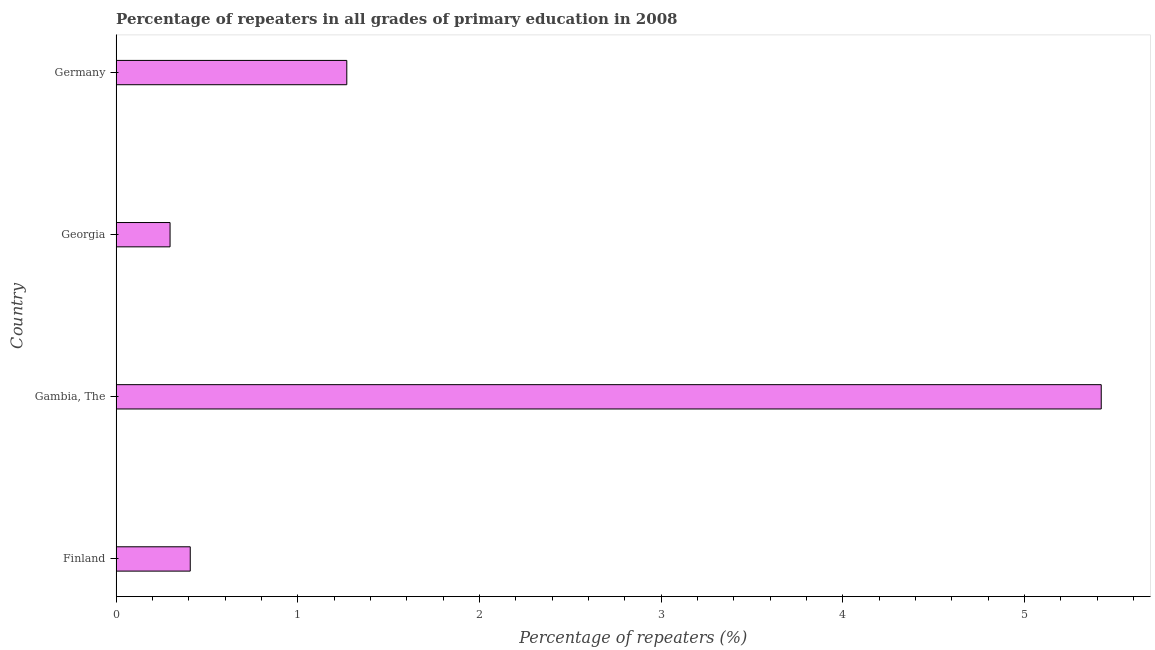Does the graph contain any zero values?
Your answer should be compact. No. What is the title of the graph?
Provide a succinct answer. Percentage of repeaters in all grades of primary education in 2008. What is the label or title of the X-axis?
Make the answer very short. Percentage of repeaters (%). What is the label or title of the Y-axis?
Provide a succinct answer. Country. What is the percentage of repeaters in primary education in Georgia?
Offer a terse response. 0.3. Across all countries, what is the maximum percentage of repeaters in primary education?
Provide a short and direct response. 5.42. Across all countries, what is the minimum percentage of repeaters in primary education?
Your response must be concise. 0.3. In which country was the percentage of repeaters in primary education maximum?
Offer a very short reply. Gambia, The. In which country was the percentage of repeaters in primary education minimum?
Offer a terse response. Georgia. What is the sum of the percentage of repeaters in primary education?
Offer a terse response. 7.4. What is the difference between the percentage of repeaters in primary education in Finland and Germany?
Give a very brief answer. -0.86. What is the average percentage of repeaters in primary education per country?
Provide a short and direct response. 1.85. What is the median percentage of repeaters in primary education?
Your response must be concise. 0.84. What is the ratio of the percentage of repeaters in primary education in Finland to that in Georgia?
Offer a very short reply. 1.37. Is the difference between the percentage of repeaters in primary education in Georgia and Germany greater than the difference between any two countries?
Your response must be concise. No. What is the difference between the highest and the second highest percentage of repeaters in primary education?
Keep it short and to the point. 4.15. Is the sum of the percentage of repeaters in primary education in Finland and Georgia greater than the maximum percentage of repeaters in primary education across all countries?
Your answer should be very brief. No. What is the difference between the highest and the lowest percentage of repeaters in primary education?
Your answer should be compact. 5.13. Are all the bars in the graph horizontal?
Your response must be concise. Yes. Are the values on the major ticks of X-axis written in scientific E-notation?
Your response must be concise. No. What is the Percentage of repeaters (%) of Finland?
Your response must be concise. 0.41. What is the Percentage of repeaters (%) of Gambia, The?
Make the answer very short. 5.42. What is the Percentage of repeaters (%) in Georgia?
Your response must be concise. 0.3. What is the Percentage of repeaters (%) of Germany?
Offer a very short reply. 1.27. What is the difference between the Percentage of repeaters (%) in Finland and Gambia, The?
Offer a terse response. -5.01. What is the difference between the Percentage of repeaters (%) in Finland and Georgia?
Your response must be concise. 0.11. What is the difference between the Percentage of repeaters (%) in Finland and Germany?
Offer a terse response. -0.86. What is the difference between the Percentage of repeaters (%) in Gambia, The and Georgia?
Your answer should be compact. 5.13. What is the difference between the Percentage of repeaters (%) in Gambia, The and Germany?
Offer a terse response. 4.15. What is the difference between the Percentage of repeaters (%) in Georgia and Germany?
Provide a short and direct response. -0.97. What is the ratio of the Percentage of repeaters (%) in Finland to that in Gambia, The?
Make the answer very short. 0.07. What is the ratio of the Percentage of repeaters (%) in Finland to that in Georgia?
Your response must be concise. 1.37. What is the ratio of the Percentage of repeaters (%) in Finland to that in Germany?
Offer a terse response. 0.32. What is the ratio of the Percentage of repeaters (%) in Gambia, The to that in Georgia?
Your answer should be compact. 18.27. What is the ratio of the Percentage of repeaters (%) in Gambia, The to that in Germany?
Your response must be concise. 4.27. What is the ratio of the Percentage of repeaters (%) in Georgia to that in Germany?
Your answer should be compact. 0.23. 